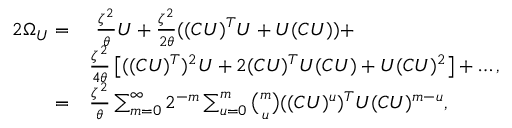<formula> <loc_0><loc_0><loc_500><loc_500>\begin{array} { r l } { 2 \Omega _ { U } = } & { \ \frac { \zeta ^ { 2 } } { \theta } U + \frac { \zeta ^ { 2 } } { 2 \theta } ( ( C U ) ^ { T } U + U ( C U ) ) + } \\ & { \frac { \zeta ^ { 2 } } { 4 \theta } \left [ ( ( C U ) ^ { T } ) ^ { 2 } U + 2 ( C U ) ^ { T } U ( C U ) + U ( C U ) ^ { 2 } \right ] + \dots , } \\ { = } & { \frac { \zeta ^ { 2 } } { \theta } \sum _ { m = 0 } ^ { \infty } { 2 ^ { - m } \sum _ { u = 0 } ^ { m } { \binom { m } { u } ( ( C U ) ^ { u } ) ^ { T } U ( C U ) ^ { m - u } } } , } \end{array}</formula> 